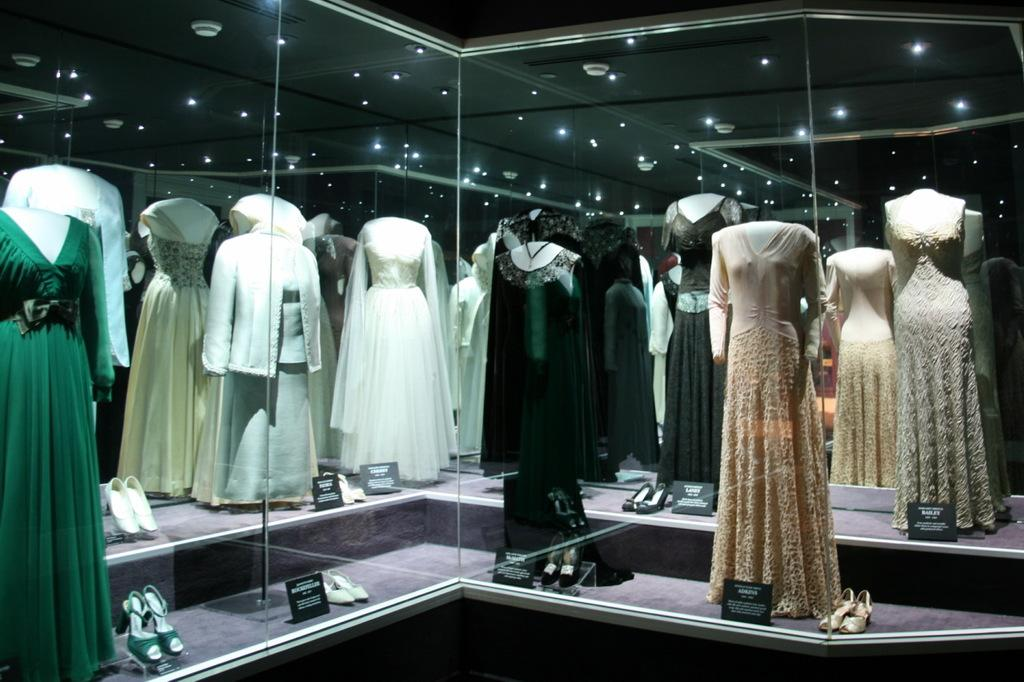What type of objects can be seen in the image? There are mannequins in the image. What kind of architectural feature is present in the image? There is a glass wall in the image. What can be seen reflected on the glass wall? The reflection of a roof with lights is visible on the glass wall. How many tomatoes are hanging from the ceiling in the image? There are no tomatoes present in the image. What type of heart-shaped object can be seen in the image? There is no heart-shaped object present in the image. 